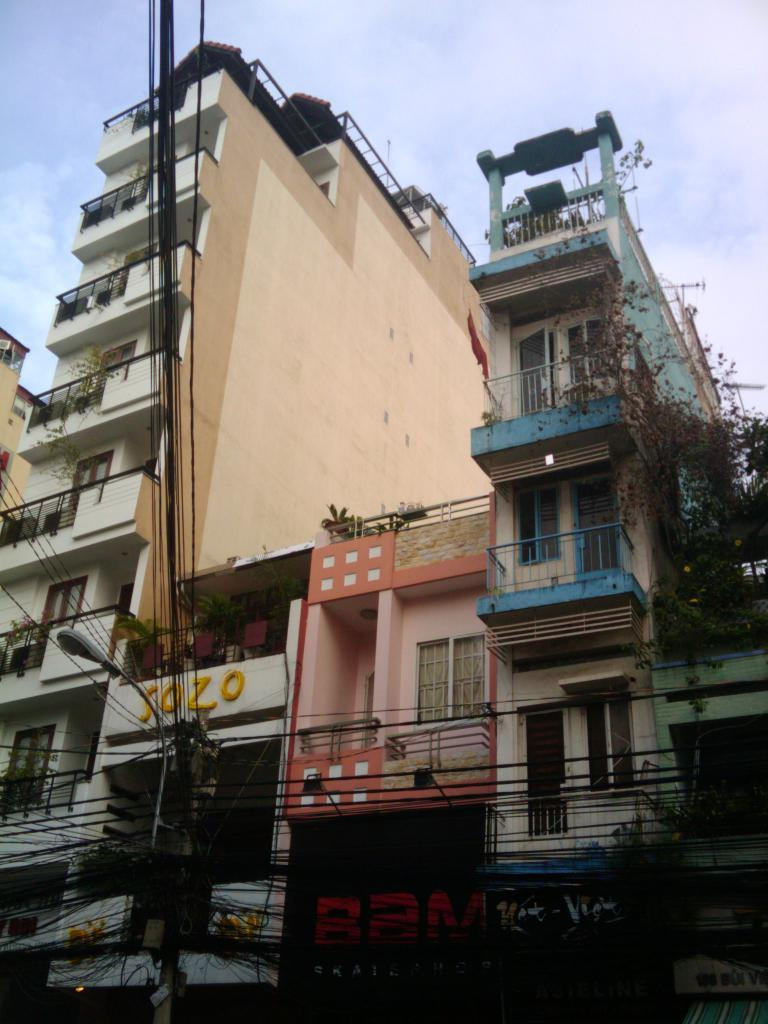What type of structures are visible in the image? There are apartments and buildings in the image. Can you describe the surroundings of the buildings? There are a lot of wires in front of the buildings. What is the belief of the person driving the car in the image? There is no person driving a car in the image; it only features apartments, buildings, and wires. 